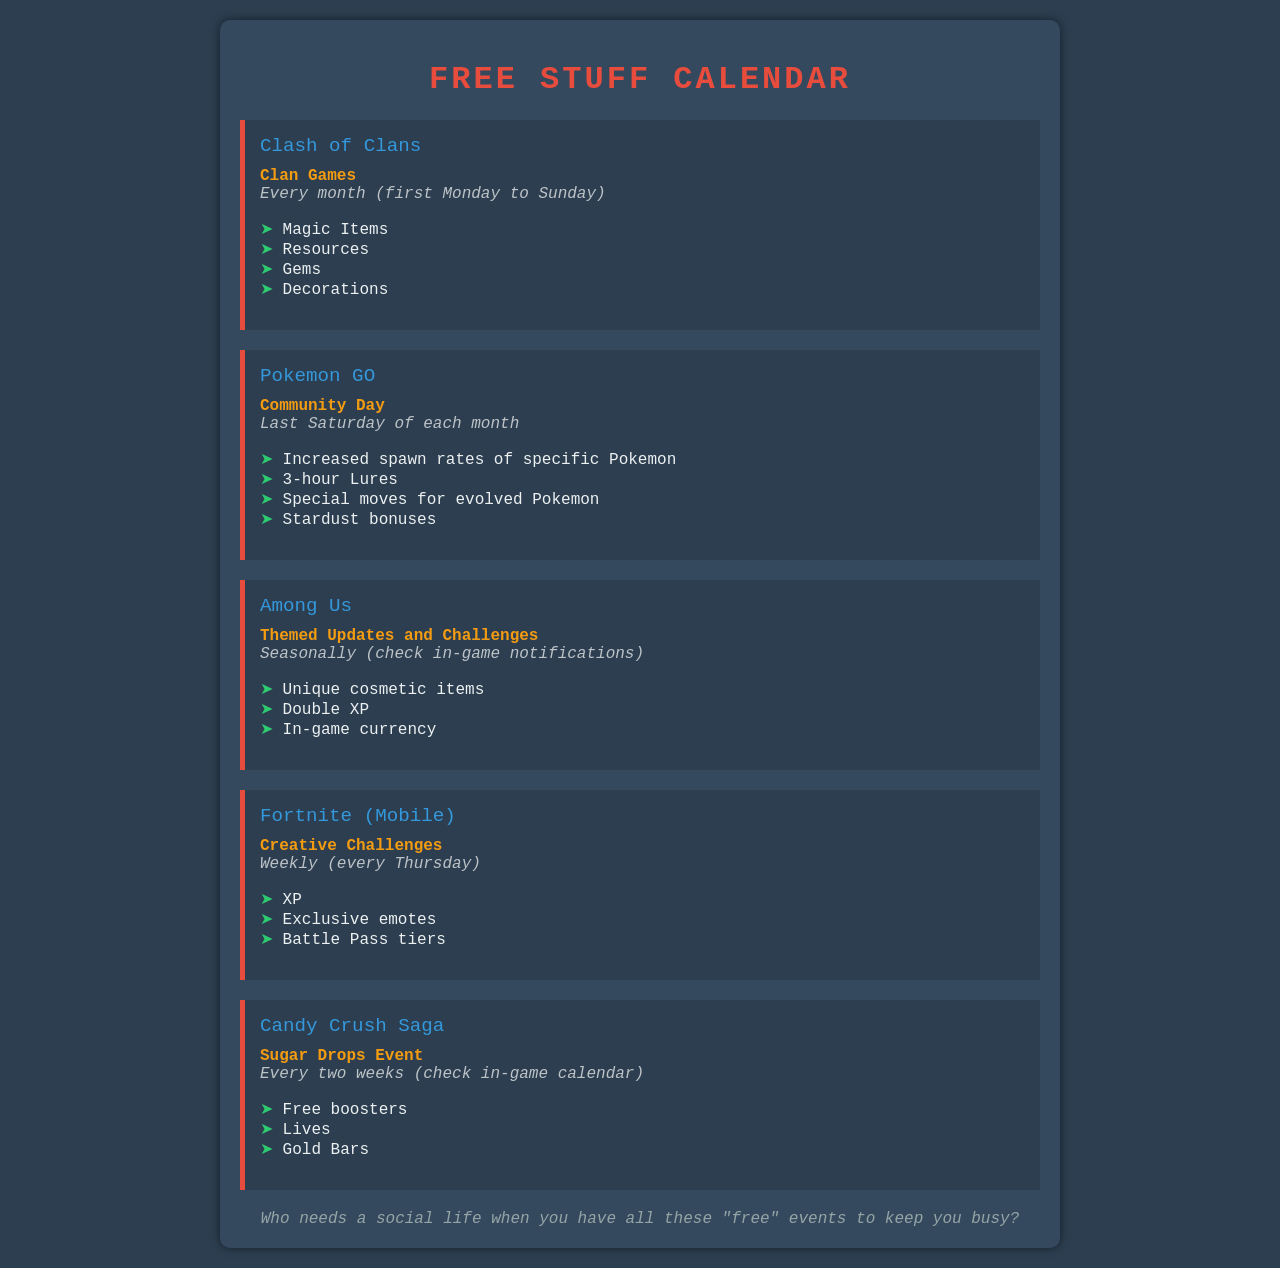What is the event name for Clash of Clans? The event name for Clash of Clans is specified in the document as Clan Games.
Answer: Clan Games When does the Pokemon GO Community Day occur? The document states that the Pokemon GO Community Day takes place on the last Saturday of each month.
Answer: Last Saturday of each month What rewards are available during the Sugar Drops Event in Candy Crush Saga? The document lists the rewards for the Sugar Drops Event, which includes free boosters, lives, and gold bars.
Answer: Free boosters, lives, gold bars How often do the Creative Challenges in Fortnite (Mobile) occur? The document indicates that Creative Challenges happen weekly, specifically every Thursday.
Answer: Weekly (every Thursday) What type of items can players earn from Among Us themed updates? The document mentions that players can earn unique cosmetic items, double XP, and in-game currency from the themed updates.
Answer: Unique cosmetic items Which game has events that occur seasonally? The document specifies that Among Us has events that occur seasonally.
Answer: Among Us What is the maximum reward tier available in Fortnite (Mobile) during Creative Challenges? The document states the rewards include Battle Pass tiers but does not specify a maximum tier.
Answer: Battle Pass tiers What rewards do players receive for participating in the Clash of Clans Clan Games? The document enumerates the rewards for Clan Games, including magic items, resources, gems, and decorations.
Answer: Magic items, resources, gems, decorations What is the duration of the special bonuses during Pokemon GO Community Day? The document mentions that during Community Day players receive bonuses for a 3-hour duration with lures.
Answer: 3-hour Lures 